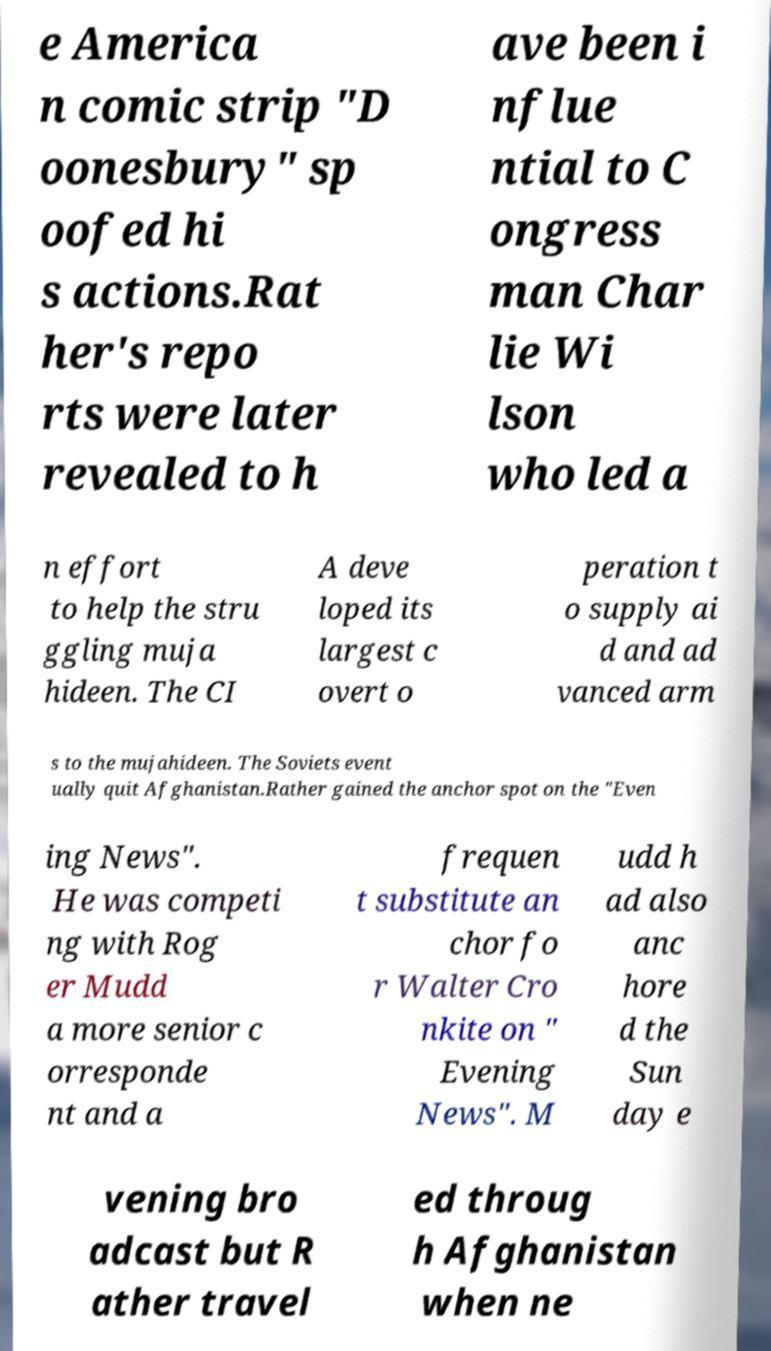Could you assist in decoding the text presented in this image and type it out clearly? e America n comic strip "D oonesbury" sp oofed hi s actions.Rat her's repo rts were later revealed to h ave been i nflue ntial to C ongress man Char lie Wi lson who led a n effort to help the stru ggling muja hideen. The CI A deve loped its largest c overt o peration t o supply ai d and ad vanced arm s to the mujahideen. The Soviets event ually quit Afghanistan.Rather gained the anchor spot on the "Even ing News". He was competi ng with Rog er Mudd a more senior c orresponde nt and a frequen t substitute an chor fo r Walter Cro nkite on " Evening News". M udd h ad also anc hore d the Sun day e vening bro adcast but R ather travel ed throug h Afghanistan when ne 